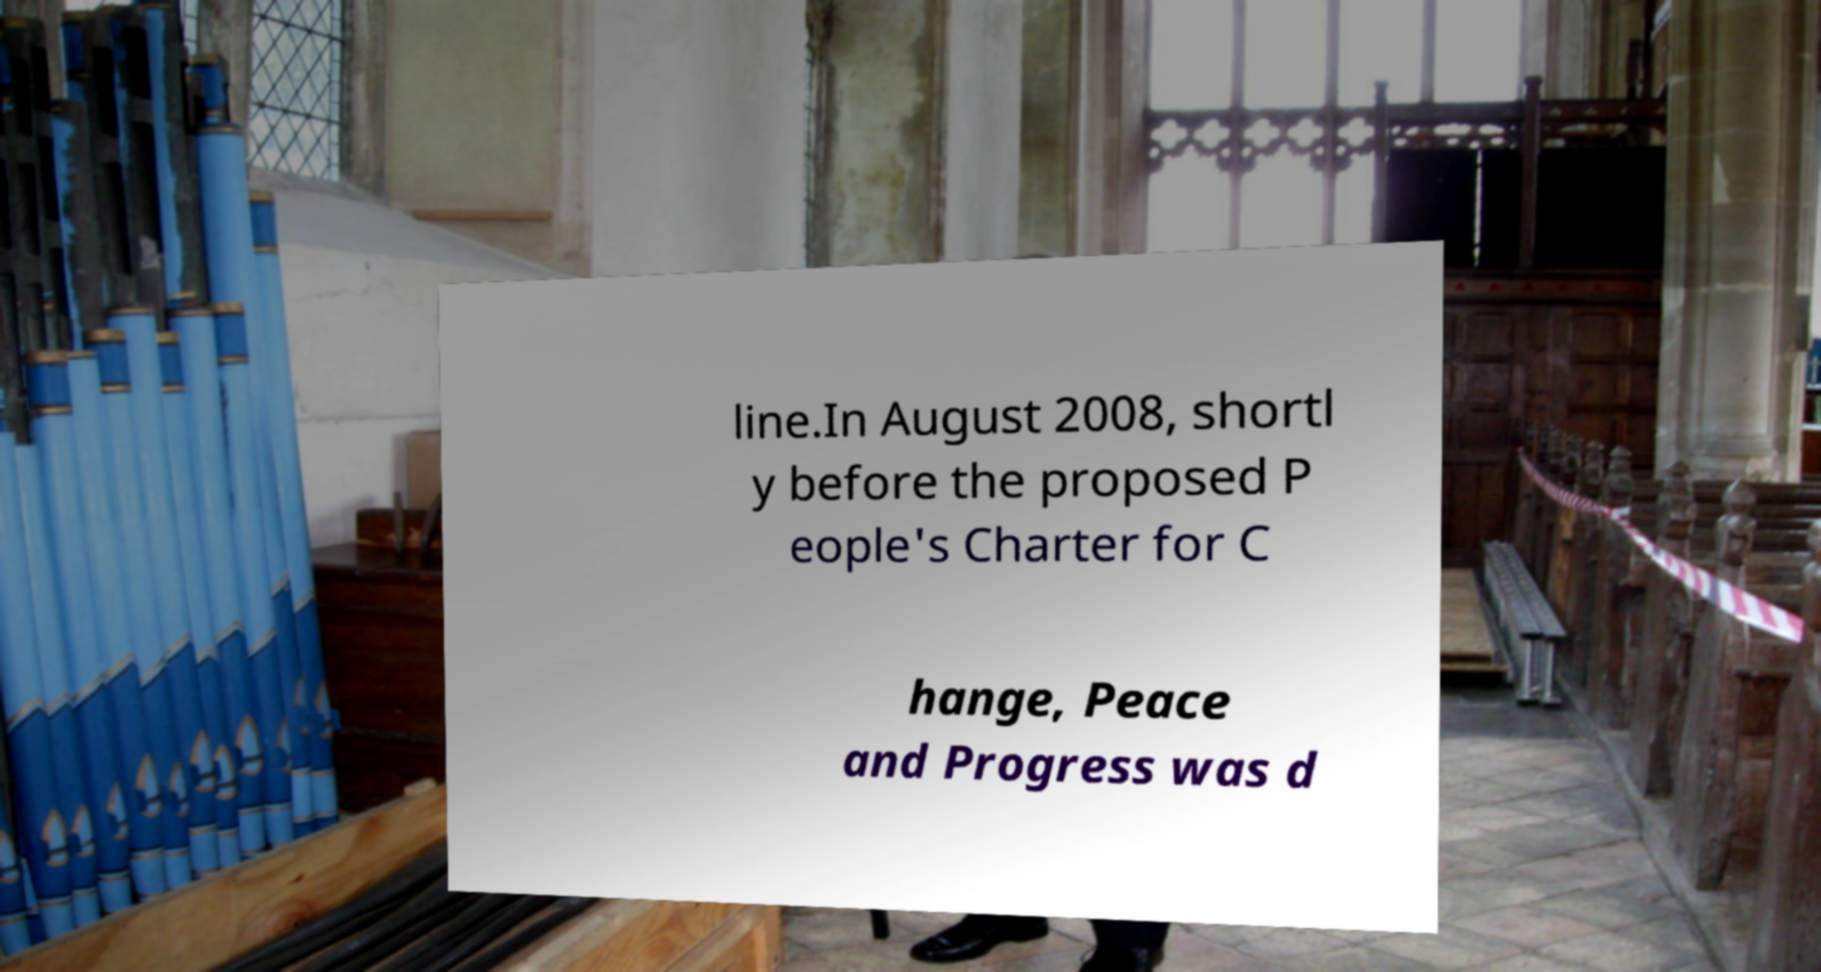Could you assist in decoding the text presented in this image and type it out clearly? line.In August 2008, shortl y before the proposed P eople's Charter for C hange, Peace and Progress was d 